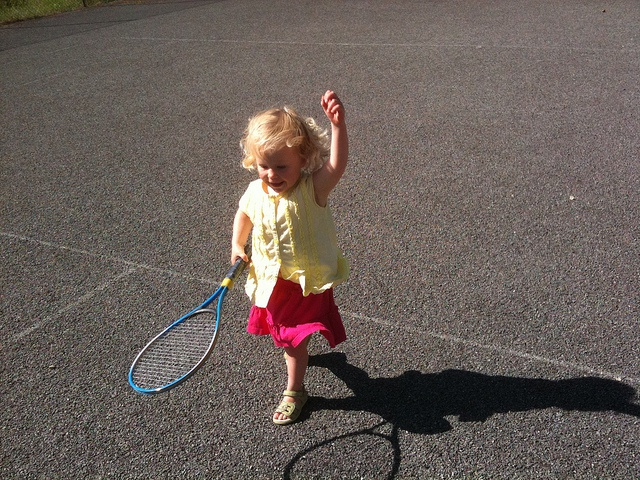Describe the objects in this image and their specific colors. I can see people in black, maroon, ivory, and gray tones and tennis racket in black, gray, and darkgray tones in this image. 